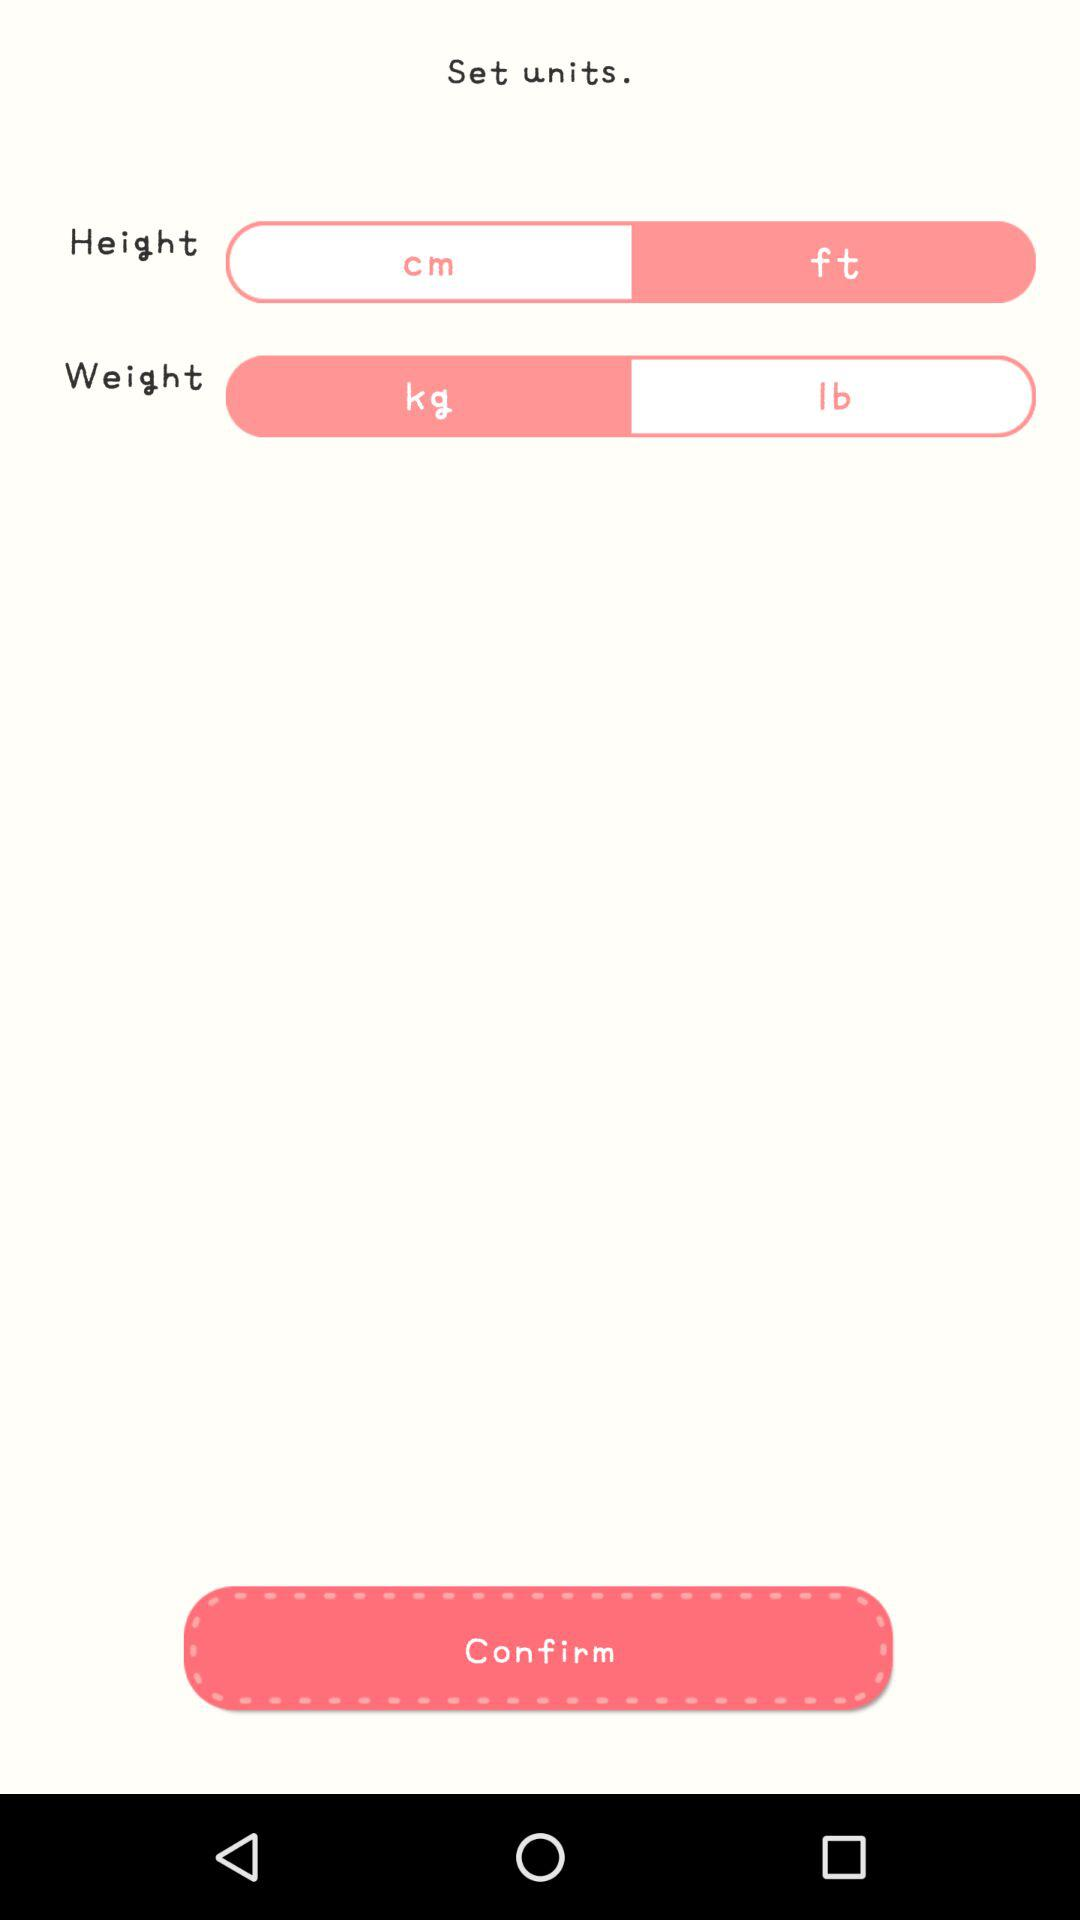What is the unit of height? The unit of height is feet. 